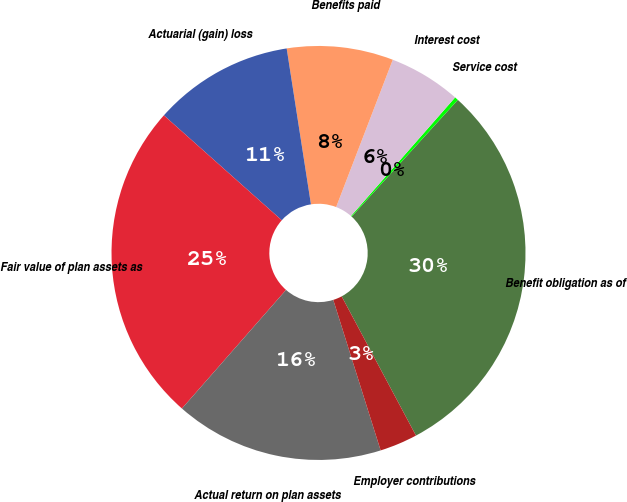<chart> <loc_0><loc_0><loc_500><loc_500><pie_chart><fcel>Benefit obligation as of<fcel>Service cost<fcel>Interest cost<fcel>Benefits paid<fcel>Actuarial (gain) loss<fcel>Fair value of plan assets as<fcel>Actual return on plan assets<fcel>Employer contributions<nl><fcel>30.45%<fcel>0.28%<fcel>5.63%<fcel>8.3%<fcel>10.97%<fcel>25.11%<fcel>16.32%<fcel>2.95%<nl></chart> 